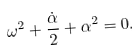<formula> <loc_0><loc_0><loc_500><loc_500>\omega ^ { 2 } + \frac { \dot { \alpha } } { 2 } + \alpha ^ { 2 } = 0 .</formula> 